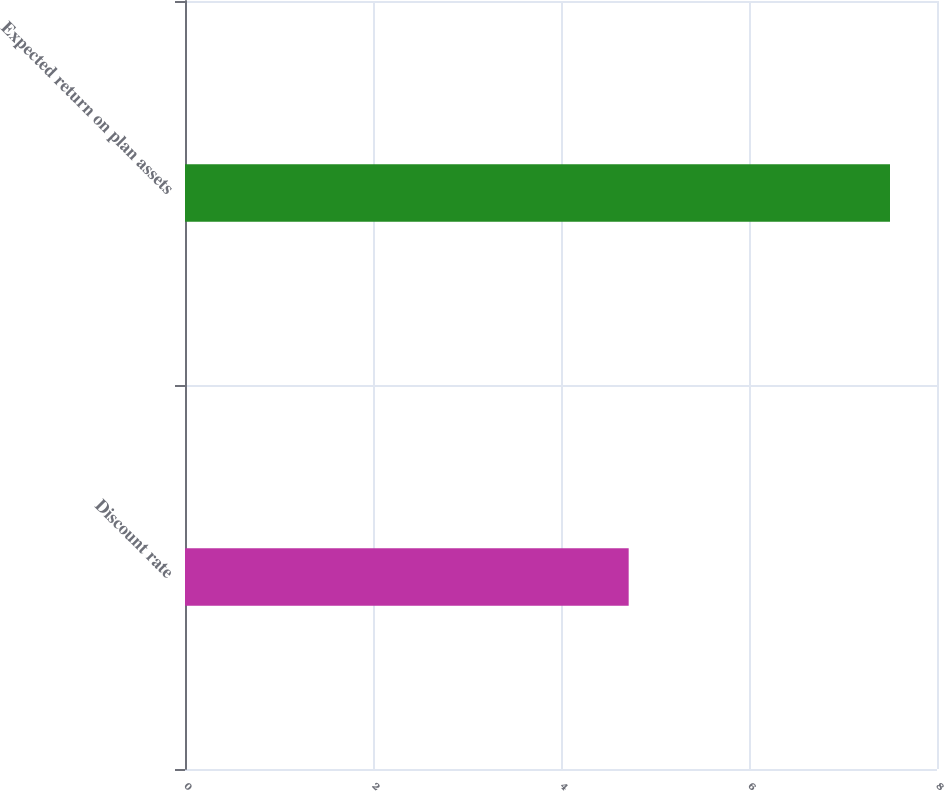Convert chart to OTSL. <chart><loc_0><loc_0><loc_500><loc_500><bar_chart><fcel>Discount rate<fcel>Expected return on plan assets<nl><fcel>4.72<fcel>7.5<nl></chart> 